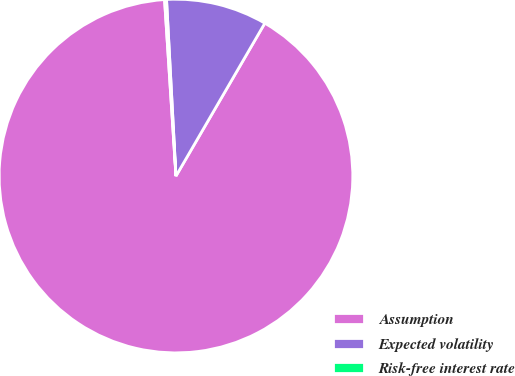Convert chart to OTSL. <chart><loc_0><loc_0><loc_500><loc_500><pie_chart><fcel>Assumption<fcel>Expected volatility<fcel>Risk-free interest rate<nl><fcel>90.59%<fcel>9.23%<fcel>0.18%<nl></chart> 